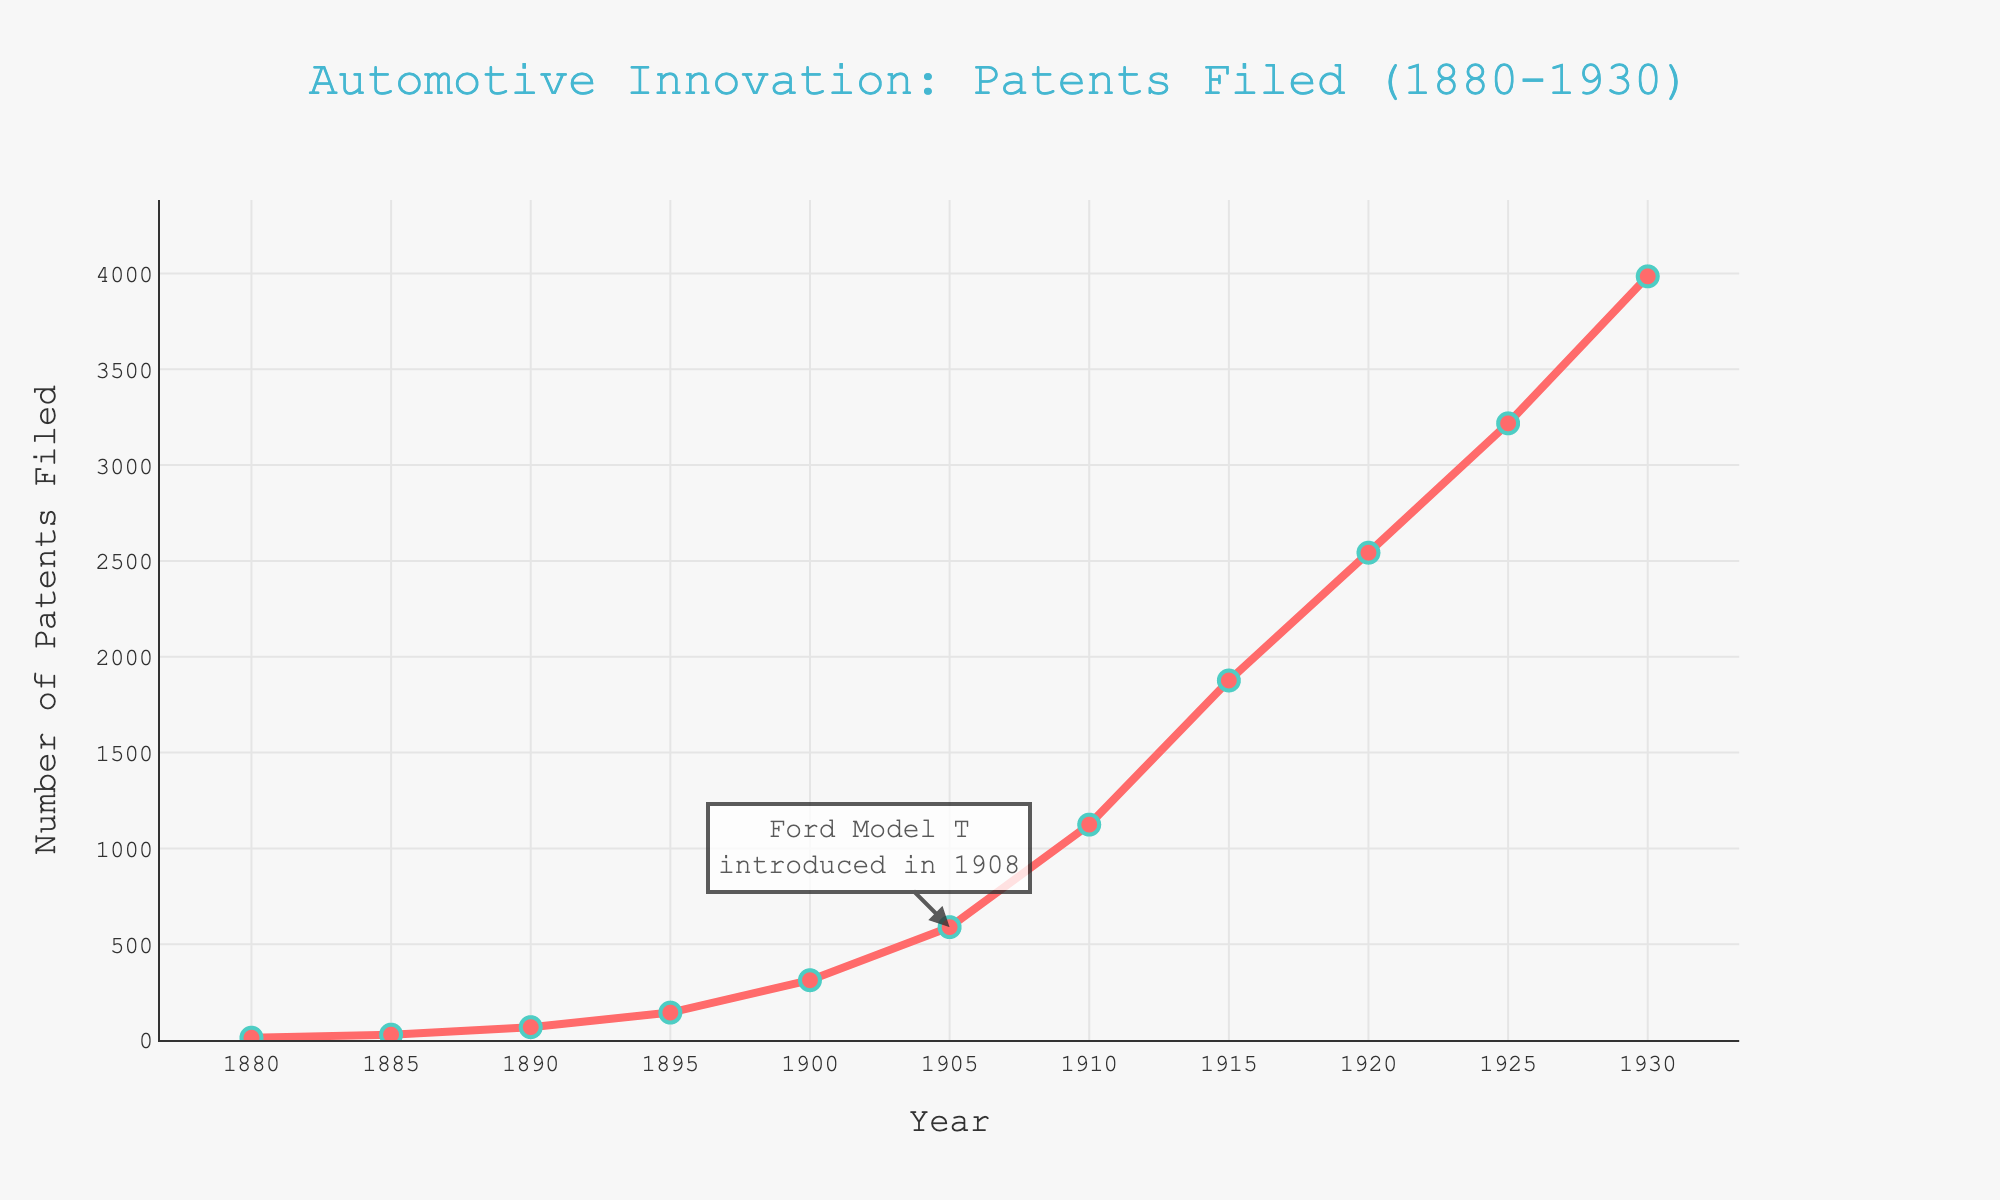What year saw the most significant increase in the number of patents filed compared to the previous year? Look for the year-over-year increases and find the largest jump in the data. The largest increase happens between 1930 and 1925 (3985 - 3218 = 767).
Answer: 1930 What's the average number of patents filed per year between 1900 and 1930? Sum the number of patents filed from 1900 to 1930 and divide by the number of years. (312 + 589 + 1124 + 1876 + 2543 + 3218 + 3985) / 7 = 1664.71
Answer: 1664.71 Which period had a higher rate of increase in the number of patents filed: 1880-1900 or 1900-1930? Calculate the increase for each period. From 1880-1900: 312 - 12 = 300. From 1900-1930: 3985 - 312 = 3673. 3673 > 300, so 1900-1930 had a higher increase.
Answer: 1900-1930 Between which consecutive years did the number of patents filed first exceed 1000? Find the first pair where the patents filed are more than 1000. From the data, 1905 (589) to 1910 (1124). So, after 1905, it exceeded 1000 in 1910.
Answer: 1905 to 1910 What can you infer from the annotation pointing to 1905? The annotation mentions the introduction of the Ford Model T in 1908. The increase in patents around 1905 might be related to innovations spurred by this significant event.
Answer: Ford Model T How much did the number of patents filed increase from 1910 to 1930? Subtract the number of patents filed in 1910 from the number filed in 1930. (3985 - 1124 = 2861)
Answer: 2861 What is the relationship between the year and the number of patents filed from 1880 to 1930? Observing the line chart shows a general upward trend in the number of patents filed over these years, indicating increasing automotive innovations.
Answer: Increasing trend How many more patents were filed in 1925 compared to 1910? Subtract the number of patents filed in 1910 from the number filed in 1925. (3218 - 1124 = 2094)
Answer: 2094 